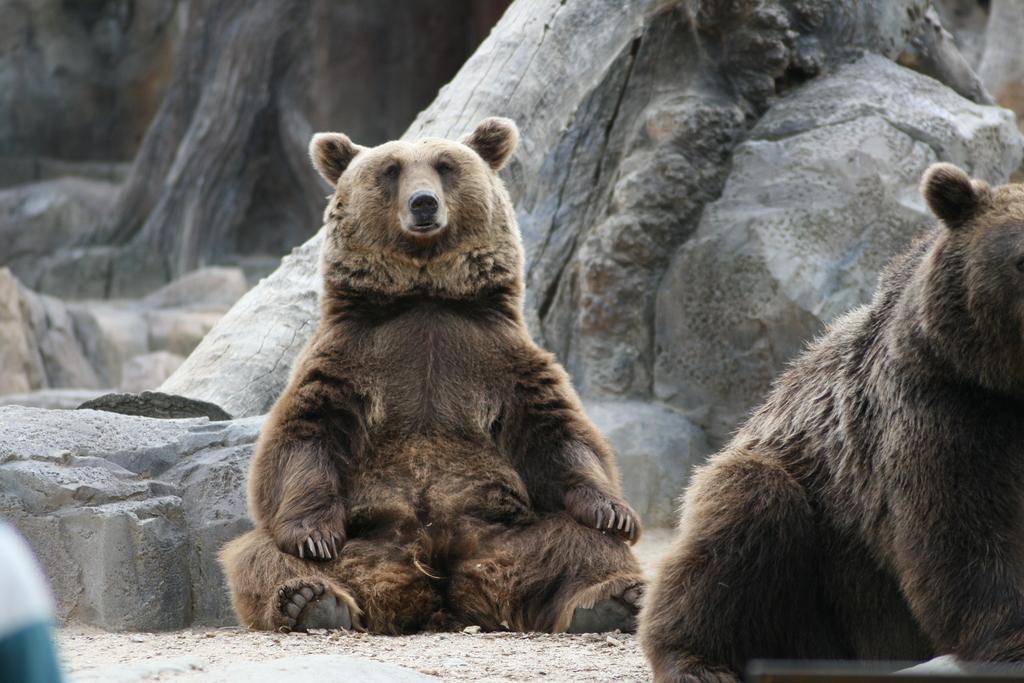Describe this image in one or two sentences. It is a bear which is in brown color, behind this there are stones. On the right side there is another bear. 